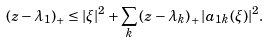<formula> <loc_0><loc_0><loc_500><loc_500>\left ( z - \lambda _ { 1 } \right ) _ { + } \leq | \xi | ^ { 2 } + \sum _ { k } \left ( z - \lambda _ { k } \right ) _ { + } | a _ { 1 k } ( \xi ) | ^ { 2 } .</formula> 